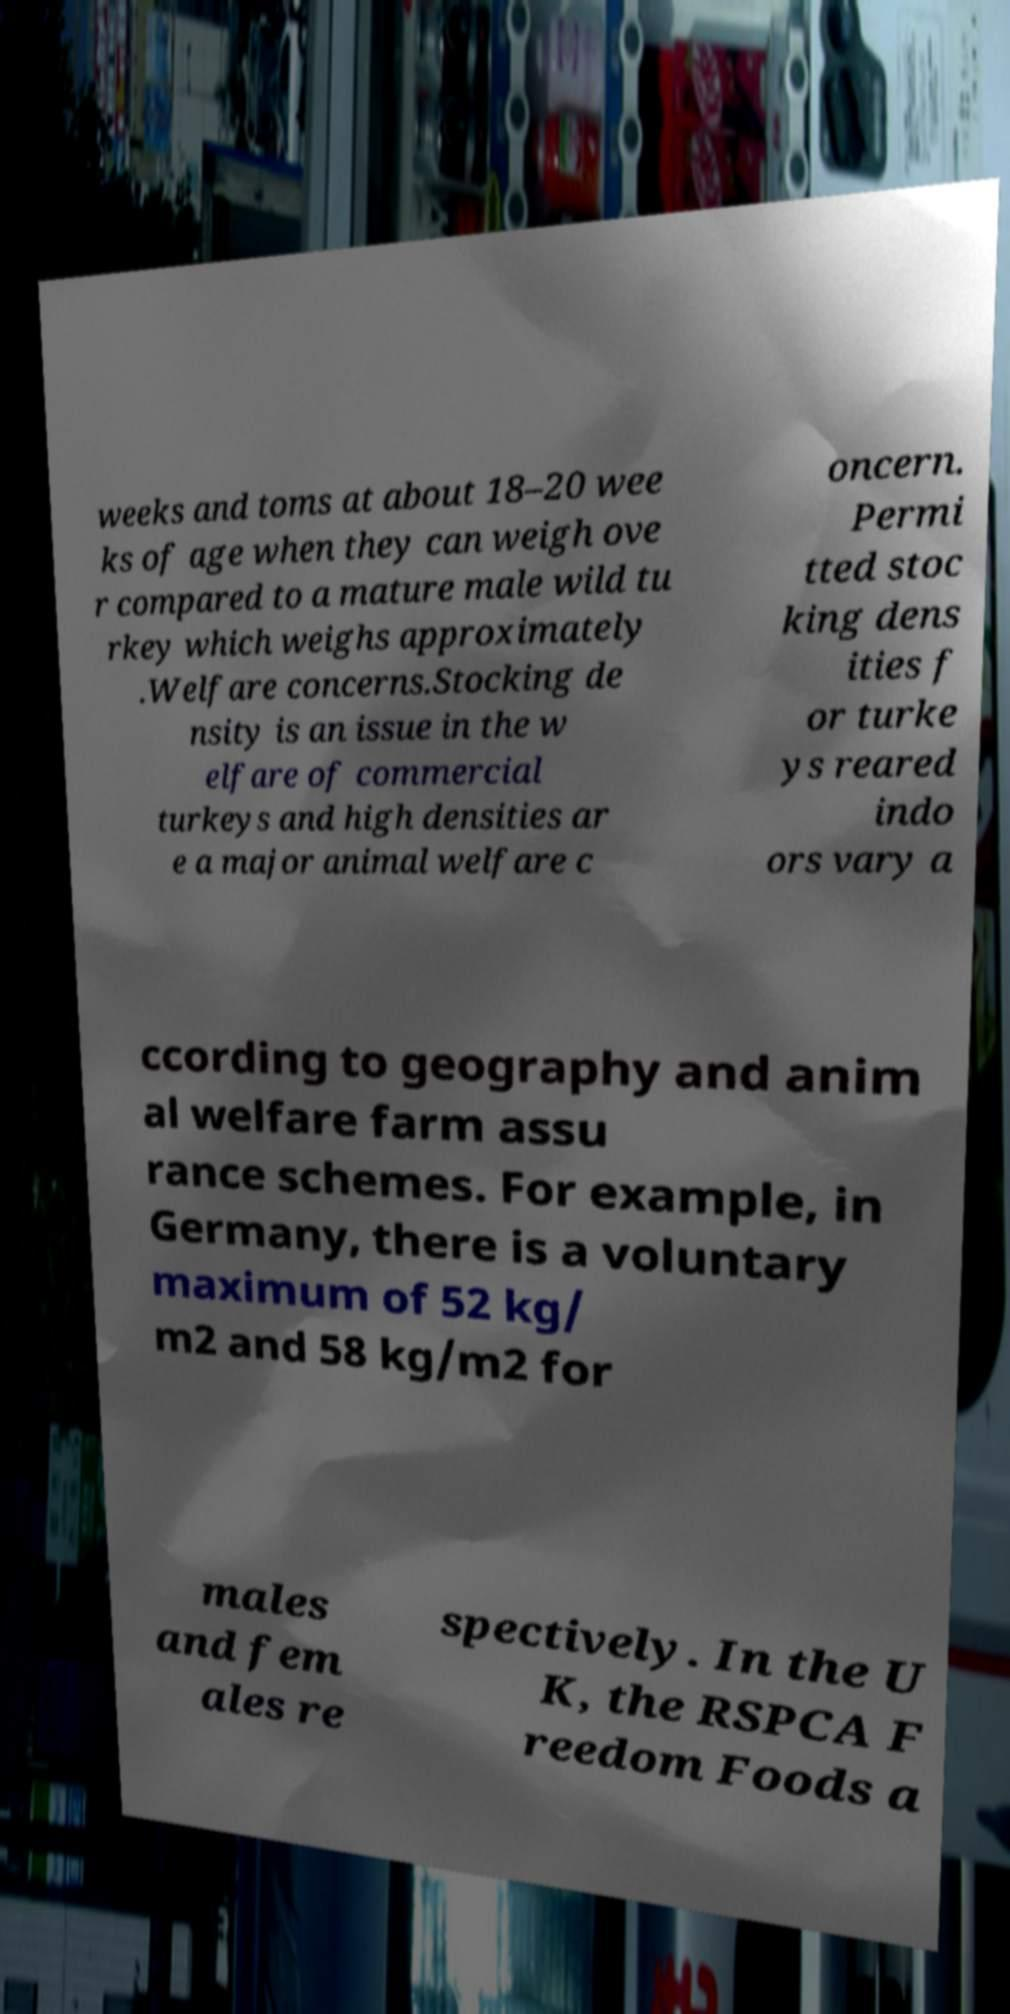For documentation purposes, I need the text within this image transcribed. Could you provide that? weeks and toms at about 18–20 wee ks of age when they can weigh ove r compared to a mature male wild tu rkey which weighs approximately .Welfare concerns.Stocking de nsity is an issue in the w elfare of commercial turkeys and high densities ar e a major animal welfare c oncern. Permi tted stoc king dens ities f or turke ys reared indo ors vary a ccording to geography and anim al welfare farm assu rance schemes. For example, in Germany, there is a voluntary maximum of 52 kg/ m2 and 58 kg/m2 for males and fem ales re spectively. In the U K, the RSPCA F reedom Foods a 